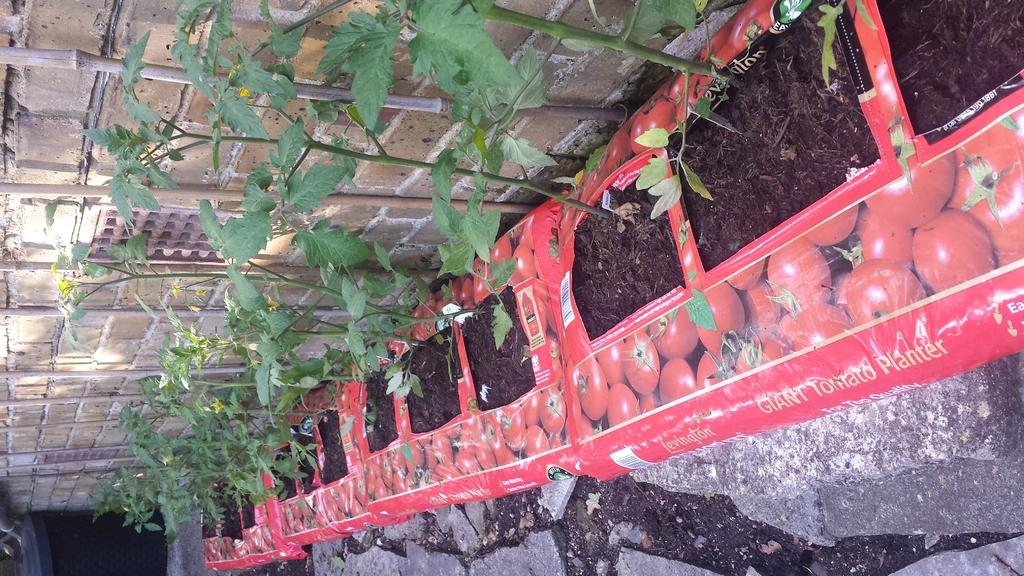What is in the mud in the image? There are plants in the mud in the image. What is used to protect or cover the mud in the image? There are covers around the mud in the image. What can be seen in the background of the image? There is a wall in the background of the image. What is located on the left side of the image? There is an unspecified object on the left side of the image. What type of acoustics can be heard from the plants in the image? There is no mention of acoustics or sounds in the image, as it features plants in mud with covers and a wall in the background. What type of leather is used to cover the mud in the image? There is no mention of leather in the image; the covers around the mud are not specified. 